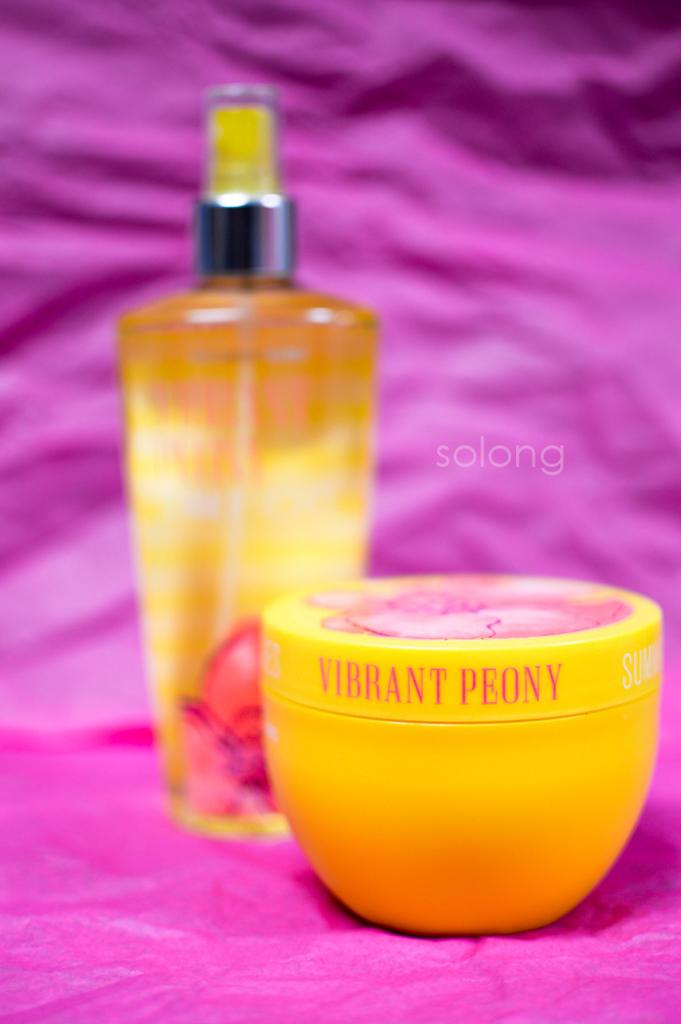<image>
Summarize the visual content of the image. A pink and yellow jar and bottle of Vibrant Peony cosmetics. 